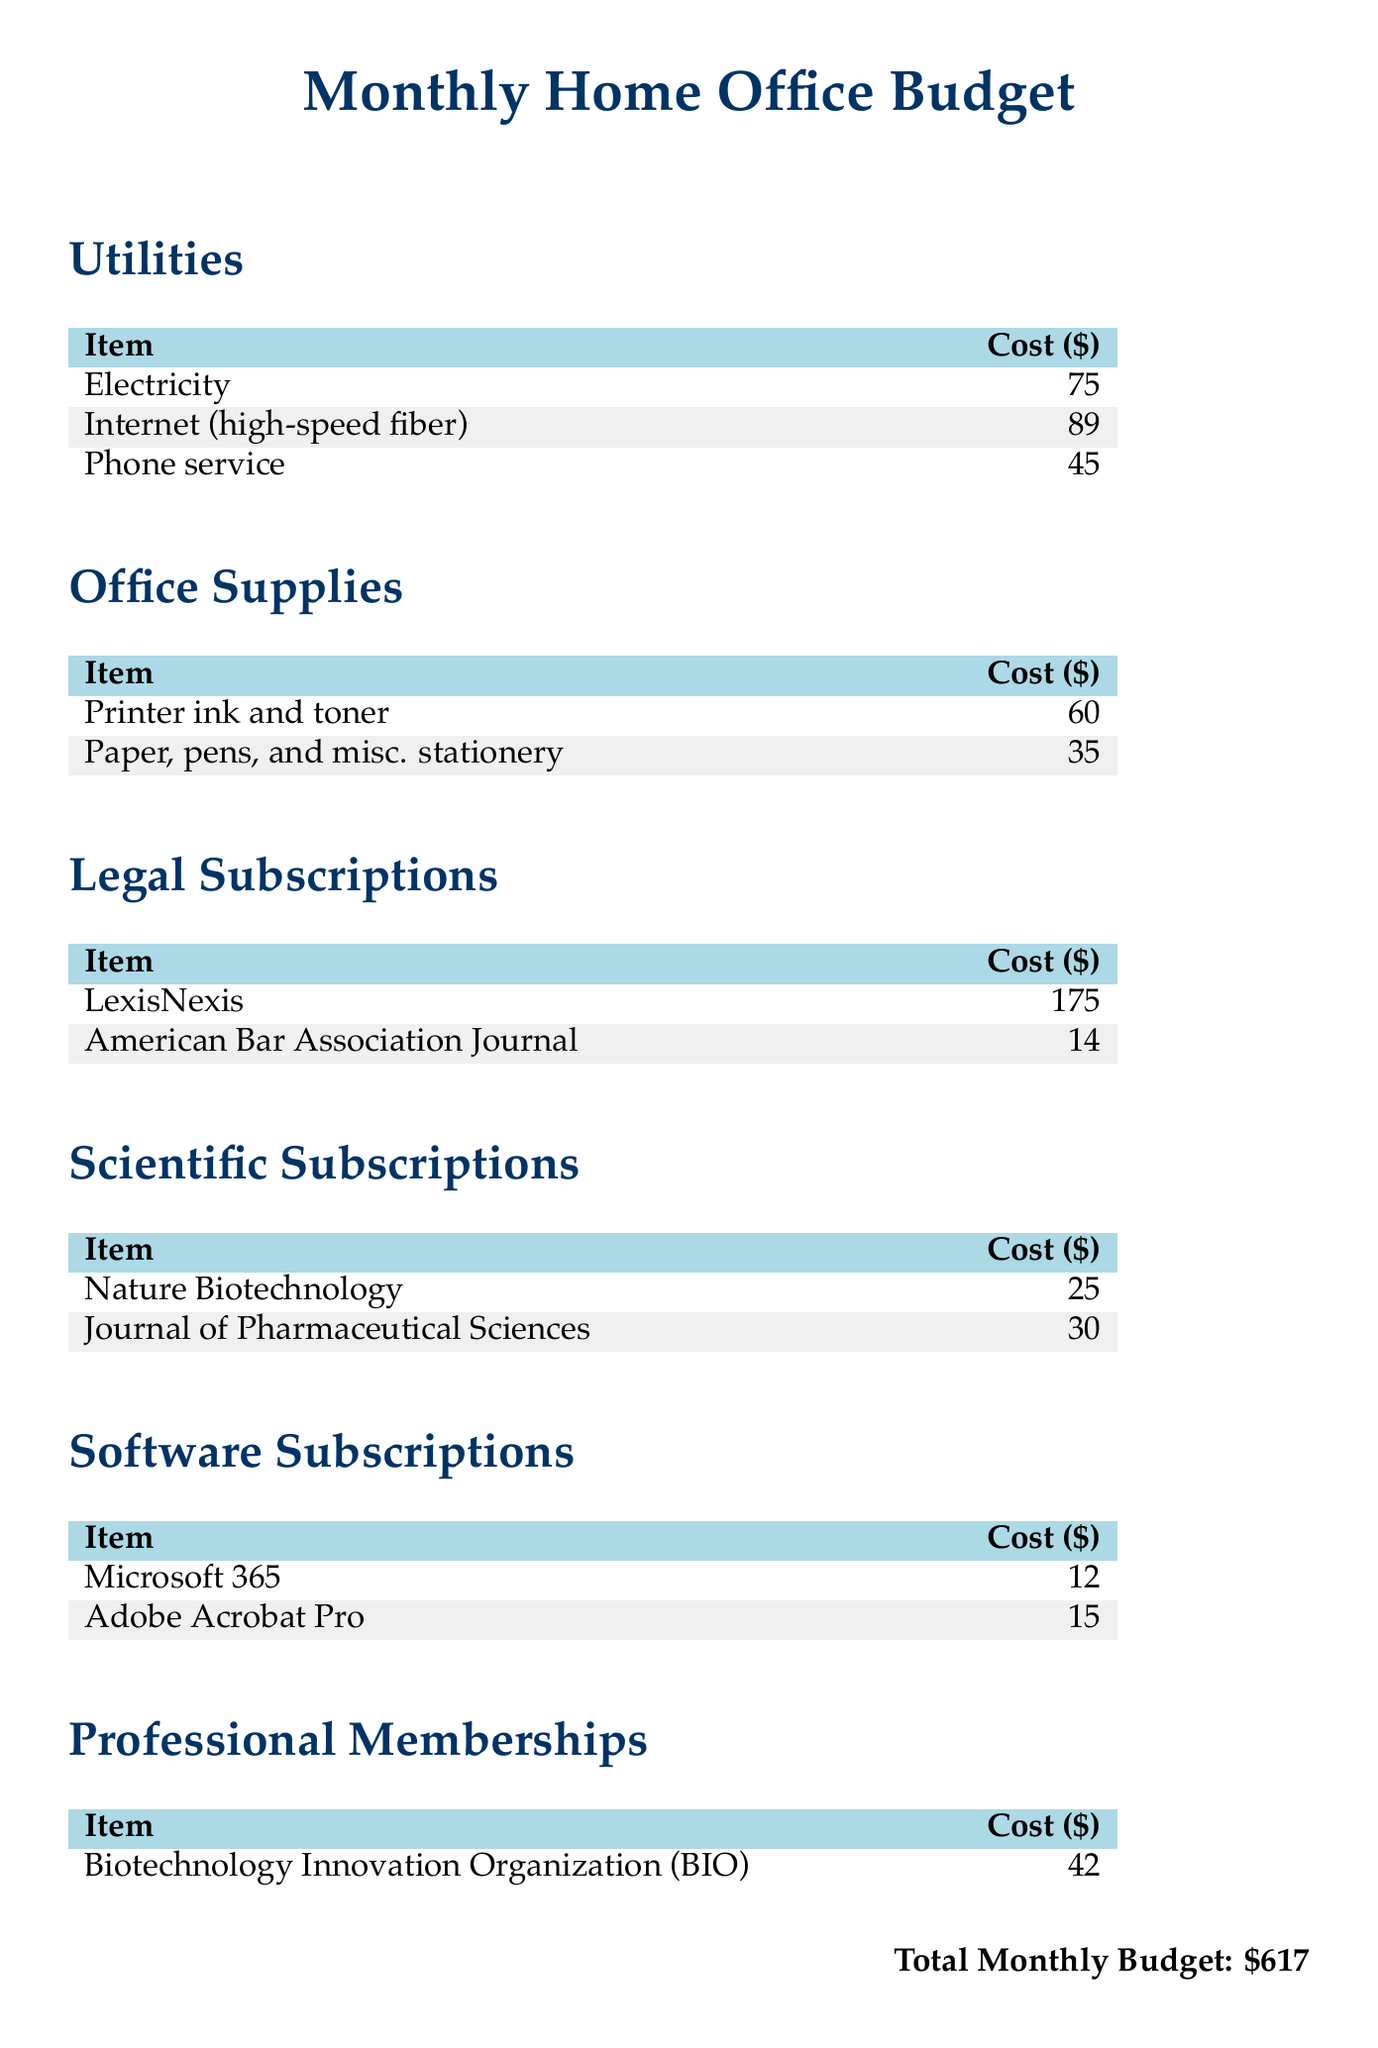What is the total cost for utilities? The total cost for utilities is the sum of the individual utility costs, which are 75 + 89 + 45 = 209.
Answer: 209 How much does the LexisNexis subscription cost? The cost for the LexisNexis subscription is listed under Legal Subscriptions in the document.
Answer: 175 What supplies are included under Office Supplies? Office Supplies includes costs for printer ink and toner, as well as paper, pens, and miscellaneous stationery.
Answer: Printer ink and toner; Paper, pens, and misc. stationery What is the monthly cost for Adobe Acrobat Pro? The monthly cost for Adobe Acrobat Pro is specified under Software Subscriptions.
Answer: 15 How many scientific subscriptions are mentioned? The document lists two scientific subscriptions, therefore the number is derived from the count of items listed in that section.
Answer: 2 What is the total monthly budget? The total monthly budget is the overall sum of all the expenses listed throughout the document.
Answer: 617 Which professional membership is included and its cost? The document states the only professional membership listed is Biotechnology Innovation Organization (BIO) at a specific cost.
Answer: Biotechnology Innovation Organization (BIO); 42 What is the cost of the Journal of Pharmaceutical Sciences? The cost of the Journal of Pharmaceutical Sciences is found in the Scientific Subscriptions section of the document.
Answer: 30 Which utility has the highest cost? The utility with the highest cost can be determined by comparing the costs of Electricity, Internet, and Phone service listed in the document.
Answer: Internet (high-speed fiber) 